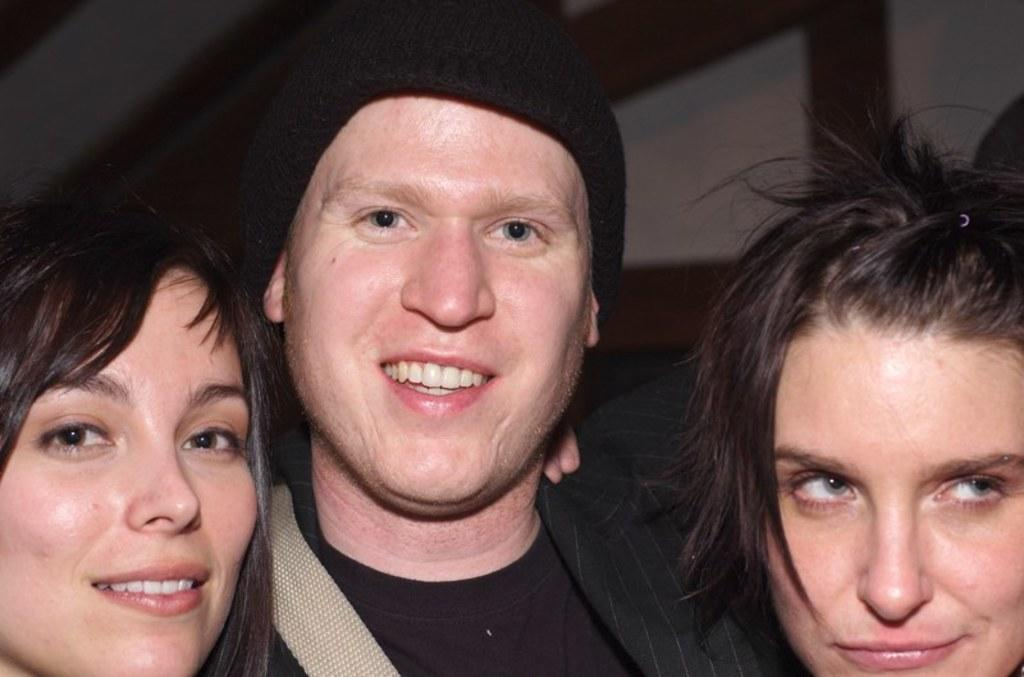How many people are present in the image? There are two people in the image. What expressions do the people have on their faces? Both people are wearing smiles on their faces. Is there anyone else present in the image besides the two people? Yes, there is another person beside them. What type of plantation can be seen in the background of the image? There is no plantation visible in the image; it only features the three people. What type of furniture is present in the image? There is no furniture, such as a sofa, present in the image. 